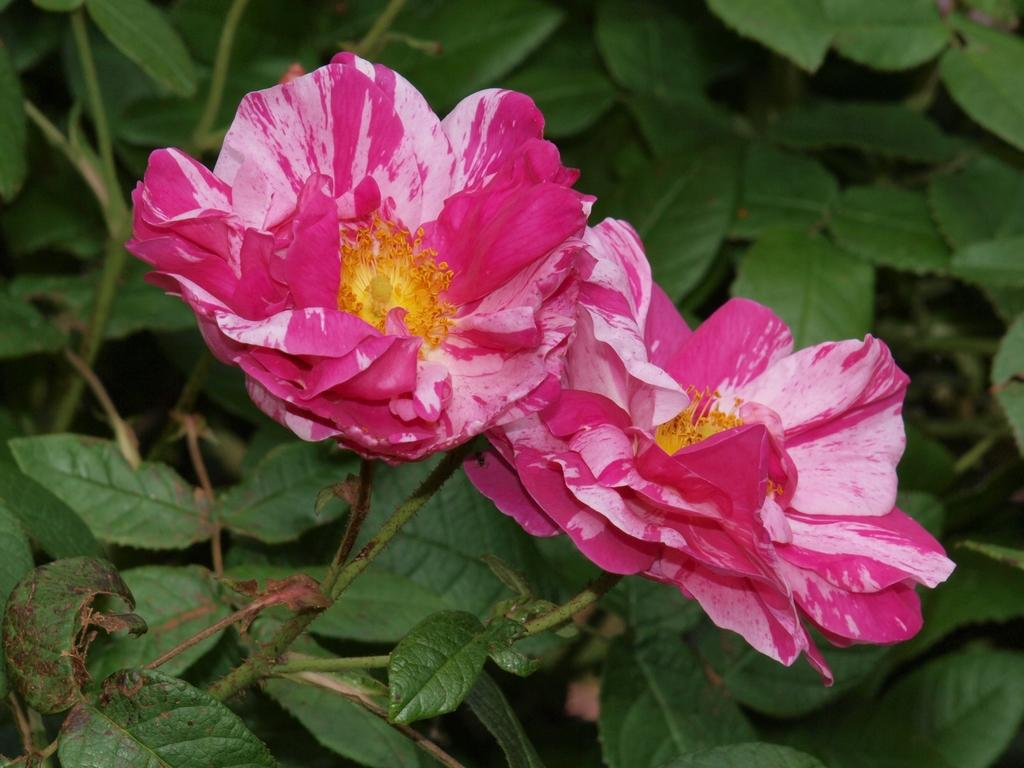What type of vegetation is present in the image? There are green leaves and pink flowers in the image. Can you describe the colors of the vegetation? The green leaves and pink flowers are the main colors visible in the image. What is the chance of winning the lottery in the image? There is no mention of a lottery or any chance of winning in the image, as it only features green leaves and pink flowers. 